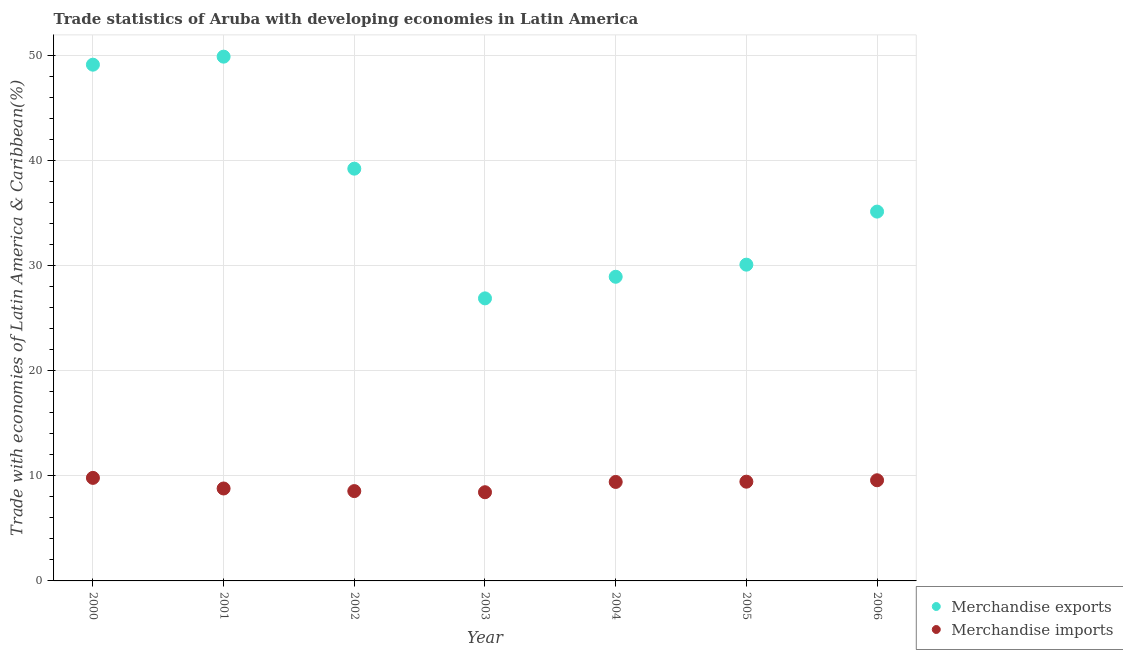Is the number of dotlines equal to the number of legend labels?
Keep it short and to the point. Yes. What is the merchandise exports in 2001?
Provide a succinct answer. 49.86. Across all years, what is the maximum merchandise imports?
Offer a terse response. 9.8. Across all years, what is the minimum merchandise exports?
Make the answer very short. 26.87. In which year was the merchandise exports maximum?
Your answer should be compact. 2001. What is the total merchandise exports in the graph?
Provide a short and direct response. 259.17. What is the difference between the merchandise exports in 2001 and that in 2003?
Offer a very short reply. 22.99. What is the difference between the merchandise exports in 2004 and the merchandise imports in 2005?
Your answer should be compact. 19.49. What is the average merchandise exports per year?
Keep it short and to the point. 37.02. In the year 2005, what is the difference between the merchandise imports and merchandise exports?
Provide a short and direct response. -20.64. In how many years, is the merchandise imports greater than 46 %?
Offer a very short reply. 0. What is the ratio of the merchandise exports in 2001 to that in 2002?
Ensure brevity in your answer.  1.27. Is the merchandise imports in 2000 less than that in 2006?
Provide a succinct answer. No. What is the difference between the highest and the second highest merchandise imports?
Your answer should be compact. 0.23. What is the difference between the highest and the lowest merchandise imports?
Your response must be concise. 1.36. Is the merchandise imports strictly greater than the merchandise exports over the years?
Ensure brevity in your answer.  No. Is the merchandise exports strictly less than the merchandise imports over the years?
Provide a succinct answer. No. How many years are there in the graph?
Your response must be concise. 7. What is the difference between two consecutive major ticks on the Y-axis?
Ensure brevity in your answer.  10. Are the values on the major ticks of Y-axis written in scientific E-notation?
Keep it short and to the point. No. Does the graph contain grids?
Make the answer very short. Yes. Where does the legend appear in the graph?
Ensure brevity in your answer.  Bottom right. How many legend labels are there?
Your answer should be compact. 2. What is the title of the graph?
Make the answer very short. Trade statistics of Aruba with developing economies in Latin America. Does "Chemicals" appear as one of the legend labels in the graph?
Ensure brevity in your answer.  No. What is the label or title of the X-axis?
Make the answer very short. Year. What is the label or title of the Y-axis?
Your answer should be very brief. Trade with economies of Latin America & Caribbean(%). What is the Trade with economies of Latin America & Caribbean(%) in Merchandise exports in 2000?
Give a very brief answer. 49.1. What is the Trade with economies of Latin America & Caribbean(%) of Merchandise imports in 2000?
Your answer should be very brief. 9.8. What is the Trade with economies of Latin America & Caribbean(%) of Merchandise exports in 2001?
Ensure brevity in your answer.  49.86. What is the Trade with economies of Latin America & Caribbean(%) in Merchandise imports in 2001?
Your response must be concise. 8.79. What is the Trade with economies of Latin America & Caribbean(%) of Merchandise exports in 2002?
Offer a very short reply. 39.21. What is the Trade with economies of Latin America & Caribbean(%) in Merchandise imports in 2002?
Offer a very short reply. 8.54. What is the Trade with economies of Latin America & Caribbean(%) in Merchandise exports in 2003?
Your response must be concise. 26.87. What is the Trade with economies of Latin America & Caribbean(%) of Merchandise imports in 2003?
Ensure brevity in your answer.  8.44. What is the Trade with economies of Latin America & Caribbean(%) in Merchandise exports in 2004?
Your answer should be compact. 28.93. What is the Trade with economies of Latin America & Caribbean(%) of Merchandise imports in 2004?
Your answer should be compact. 9.41. What is the Trade with economies of Latin America & Caribbean(%) of Merchandise exports in 2005?
Offer a terse response. 30.08. What is the Trade with economies of Latin America & Caribbean(%) in Merchandise imports in 2005?
Provide a succinct answer. 9.44. What is the Trade with economies of Latin America & Caribbean(%) in Merchandise exports in 2006?
Your answer should be compact. 35.12. What is the Trade with economies of Latin America & Caribbean(%) of Merchandise imports in 2006?
Your response must be concise. 9.57. Across all years, what is the maximum Trade with economies of Latin America & Caribbean(%) of Merchandise exports?
Your response must be concise. 49.86. Across all years, what is the maximum Trade with economies of Latin America & Caribbean(%) of Merchandise imports?
Your answer should be compact. 9.8. Across all years, what is the minimum Trade with economies of Latin America & Caribbean(%) of Merchandise exports?
Provide a short and direct response. 26.87. Across all years, what is the minimum Trade with economies of Latin America & Caribbean(%) of Merchandise imports?
Offer a terse response. 8.44. What is the total Trade with economies of Latin America & Caribbean(%) in Merchandise exports in the graph?
Your answer should be compact. 259.17. What is the total Trade with economies of Latin America & Caribbean(%) in Merchandise imports in the graph?
Make the answer very short. 63.99. What is the difference between the Trade with economies of Latin America & Caribbean(%) in Merchandise exports in 2000 and that in 2001?
Your response must be concise. -0.76. What is the difference between the Trade with economies of Latin America & Caribbean(%) of Merchandise imports in 2000 and that in 2001?
Give a very brief answer. 1.01. What is the difference between the Trade with economies of Latin America & Caribbean(%) in Merchandise exports in 2000 and that in 2002?
Your answer should be compact. 9.89. What is the difference between the Trade with economies of Latin America & Caribbean(%) of Merchandise imports in 2000 and that in 2002?
Your answer should be very brief. 1.26. What is the difference between the Trade with economies of Latin America & Caribbean(%) in Merchandise exports in 2000 and that in 2003?
Give a very brief answer. 22.23. What is the difference between the Trade with economies of Latin America & Caribbean(%) in Merchandise imports in 2000 and that in 2003?
Your response must be concise. 1.36. What is the difference between the Trade with economies of Latin America & Caribbean(%) in Merchandise exports in 2000 and that in 2004?
Keep it short and to the point. 20.17. What is the difference between the Trade with economies of Latin America & Caribbean(%) in Merchandise imports in 2000 and that in 2004?
Offer a terse response. 0.39. What is the difference between the Trade with economies of Latin America & Caribbean(%) in Merchandise exports in 2000 and that in 2005?
Give a very brief answer. 19.02. What is the difference between the Trade with economies of Latin America & Caribbean(%) in Merchandise imports in 2000 and that in 2005?
Ensure brevity in your answer.  0.36. What is the difference between the Trade with economies of Latin America & Caribbean(%) in Merchandise exports in 2000 and that in 2006?
Offer a terse response. 13.97. What is the difference between the Trade with economies of Latin America & Caribbean(%) in Merchandise imports in 2000 and that in 2006?
Your answer should be very brief. 0.23. What is the difference between the Trade with economies of Latin America & Caribbean(%) in Merchandise exports in 2001 and that in 2002?
Your answer should be very brief. 10.65. What is the difference between the Trade with economies of Latin America & Caribbean(%) in Merchandise imports in 2001 and that in 2002?
Ensure brevity in your answer.  0.25. What is the difference between the Trade with economies of Latin America & Caribbean(%) in Merchandise exports in 2001 and that in 2003?
Provide a short and direct response. 22.99. What is the difference between the Trade with economies of Latin America & Caribbean(%) in Merchandise imports in 2001 and that in 2003?
Your answer should be compact. 0.35. What is the difference between the Trade with economies of Latin America & Caribbean(%) of Merchandise exports in 2001 and that in 2004?
Your response must be concise. 20.94. What is the difference between the Trade with economies of Latin America & Caribbean(%) in Merchandise imports in 2001 and that in 2004?
Offer a very short reply. -0.62. What is the difference between the Trade with economies of Latin America & Caribbean(%) in Merchandise exports in 2001 and that in 2005?
Provide a short and direct response. 19.78. What is the difference between the Trade with economies of Latin America & Caribbean(%) in Merchandise imports in 2001 and that in 2005?
Offer a terse response. -0.65. What is the difference between the Trade with economies of Latin America & Caribbean(%) of Merchandise exports in 2001 and that in 2006?
Ensure brevity in your answer.  14.74. What is the difference between the Trade with economies of Latin America & Caribbean(%) in Merchandise imports in 2001 and that in 2006?
Provide a short and direct response. -0.78. What is the difference between the Trade with economies of Latin America & Caribbean(%) of Merchandise exports in 2002 and that in 2003?
Provide a succinct answer. 12.34. What is the difference between the Trade with economies of Latin America & Caribbean(%) of Merchandise imports in 2002 and that in 2003?
Ensure brevity in your answer.  0.11. What is the difference between the Trade with economies of Latin America & Caribbean(%) of Merchandise exports in 2002 and that in 2004?
Offer a terse response. 10.28. What is the difference between the Trade with economies of Latin America & Caribbean(%) in Merchandise imports in 2002 and that in 2004?
Your answer should be very brief. -0.87. What is the difference between the Trade with economies of Latin America & Caribbean(%) in Merchandise exports in 2002 and that in 2005?
Give a very brief answer. 9.13. What is the difference between the Trade with economies of Latin America & Caribbean(%) in Merchandise imports in 2002 and that in 2005?
Your answer should be compact. -0.89. What is the difference between the Trade with economies of Latin America & Caribbean(%) in Merchandise exports in 2002 and that in 2006?
Provide a short and direct response. 4.08. What is the difference between the Trade with economies of Latin America & Caribbean(%) in Merchandise imports in 2002 and that in 2006?
Give a very brief answer. -1.03. What is the difference between the Trade with economies of Latin America & Caribbean(%) in Merchandise exports in 2003 and that in 2004?
Make the answer very short. -2.05. What is the difference between the Trade with economies of Latin America & Caribbean(%) in Merchandise imports in 2003 and that in 2004?
Ensure brevity in your answer.  -0.98. What is the difference between the Trade with economies of Latin America & Caribbean(%) in Merchandise exports in 2003 and that in 2005?
Ensure brevity in your answer.  -3.21. What is the difference between the Trade with economies of Latin America & Caribbean(%) in Merchandise imports in 2003 and that in 2005?
Keep it short and to the point. -1. What is the difference between the Trade with economies of Latin America & Caribbean(%) of Merchandise exports in 2003 and that in 2006?
Provide a short and direct response. -8.25. What is the difference between the Trade with economies of Latin America & Caribbean(%) of Merchandise imports in 2003 and that in 2006?
Offer a terse response. -1.14. What is the difference between the Trade with economies of Latin America & Caribbean(%) of Merchandise exports in 2004 and that in 2005?
Keep it short and to the point. -1.15. What is the difference between the Trade with economies of Latin America & Caribbean(%) in Merchandise imports in 2004 and that in 2005?
Your answer should be very brief. -0.02. What is the difference between the Trade with economies of Latin America & Caribbean(%) in Merchandise exports in 2004 and that in 2006?
Your answer should be very brief. -6.2. What is the difference between the Trade with economies of Latin America & Caribbean(%) in Merchandise imports in 2004 and that in 2006?
Ensure brevity in your answer.  -0.16. What is the difference between the Trade with economies of Latin America & Caribbean(%) of Merchandise exports in 2005 and that in 2006?
Provide a short and direct response. -5.05. What is the difference between the Trade with economies of Latin America & Caribbean(%) in Merchandise imports in 2005 and that in 2006?
Your answer should be compact. -0.14. What is the difference between the Trade with economies of Latin America & Caribbean(%) in Merchandise exports in 2000 and the Trade with economies of Latin America & Caribbean(%) in Merchandise imports in 2001?
Your response must be concise. 40.31. What is the difference between the Trade with economies of Latin America & Caribbean(%) in Merchandise exports in 2000 and the Trade with economies of Latin America & Caribbean(%) in Merchandise imports in 2002?
Give a very brief answer. 40.56. What is the difference between the Trade with economies of Latin America & Caribbean(%) of Merchandise exports in 2000 and the Trade with economies of Latin America & Caribbean(%) of Merchandise imports in 2003?
Provide a short and direct response. 40.66. What is the difference between the Trade with economies of Latin America & Caribbean(%) of Merchandise exports in 2000 and the Trade with economies of Latin America & Caribbean(%) of Merchandise imports in 2004?
Your response must be concise. 39.68. What is the difference between the Trade with economies of Latin America & Caribbean(%) of Merchandise exports in 2000 and the Trade with economies of Latin America & Caribbean(%) of Merchandise imports in 2005?
Keep it short and to the point. 39.66. What is the difference between the Trade with economies of Latin America & Caribbean(%) of Merchandise exports in 2000 and the Trade with economies of Latin America & Caribbean(%) of Merchandise imports in 2006?
Offer a very short reply. 39.53. What is the difference between the Trade with economies of Latin America & Caribbean(%) of Merchandise exports in 2001 and the Trade with economies of Latin America & Caribbean(%) of Merchandise imports in 2002?
Provide a succinct answer. 41.32. What is the difference between the Trade with economies of Latin America & Caribbean(%) of Merchandise exports in 2001 and the Trade with economies of Latin America & Caribbean(%) of Merchandise imports in 2003?
Offer a very short reply. 41.43. What is the difference between the Trade with economies of Latin America & Caribbean(%) in Merchandise exports in 2001 and the Trade with economies of Latin America & Caribbean(%) in Merchandise imports in 2004?
Your answer should be compact. 40.45. What is the difference between the Trade with economies of Latin America & Caribbean(%) of Merchandise exports in 2001 and the Trade with economies of Latin America & Caribbean(%) of Merchandise imports in 2005?
Offer a terse response. 40.42. What is the difference between the Trade with economies of Latin America & Caribbean(%) in Merchandise exports in 2001 and the Trade with economies of Latin America & Caribbean(%) in Merchandise imports in 2006?
Your answer should be compact. 40.29. What is the difference between the Trade with economies of Latin America & Caribbean(%) of Merchandise exports in 2002 and the Trade with economies of Latin America & Caribbean(%) of Merchandise imports in 2003?
Offer a very short reply. 30.77. What is the difference between the Trade with economies of Latin America & Caribbean(%) in Merchandise exports in 2002 and the Trade with economies of Latin America & Caribbean(%) in Merchandise imports in 2004?
Give a very brief answer. 29.8. What is the difference between the Trade with economies of Latin America & Caribbean(%) in Merchandise exports in 2002 and the Trade with economies of Latin America & Caribbean(%) in Merchandise imports in 2005?
Your answer should be very brief. 29.77. What is the difference between the Trade with economies of Latin America & Caribbean(%) of Merchandise exports in 2002 and the Trade with economies of Latin America & Caribbean(%) of Merchandise imports in 2006?
Provide a short and direct response. 29.64. What is the difference between the Trade with economies of Latin America & Caribbean(%) in Merchandise exports in 2003 and the Trade with economies of Latin America & Caribbean(%) in Merchandise imports in 2004?
Offer a terse response. 17.46. What is the difference between the Trade with economies of Latin America & Caribbean(%) in Merchandise exports in 2003 and the Trade with economies of Latin America & Caribbean(%) in Merchandise imports in 2005?
Offer a terse response. 17.43. What is the difference between the Trade with economies of Latin America & Caribbean(%) in Merchandise exports in 2003 and the Trade with economies of Latin America & Caribbean(%) in Merchandise imports in 2006?
Your answer should be very brief. 17.3. What is the difference between the Trade with economies of Latin America & Caribbean(%) of Merchandise exports in 2004 and the Trade with economies of Latin America & Caribbean(%) of Merchandise imports in 2005?
Give a very brief answer. 19.49. What is the difference between the Trade with economies of Latin America & Caribbean(%) of Merchandise exports in 2004 and the Trade with economies of Latin America & Caribbean(%) of Merchandise imports in 2006?
Make the answer very short. 19.35. What is the difference between the Trade with economies of Latin America & Caribbean(%) in Merchandise exports in 2005 and the Trade with economies of Latin America & Caribbean(%) in Merchandise imports in 2006?
Your answer should be compact. 20.51. What is the average Trade with economies of Latin America & Caribbean(%) of Merchandise exports per year?
Provide a short and direct response. 37.02. What is the average Trade with economies of Latin America & Caribbean(%) of Merchandise imports per year?
Your answer should be very brief. 9.14. In the year 2000, what is the difference between the Trade with economies of Latin America & Caribbean(%) in Merchandise exports and Trade with economies of Latin America & Caribbean(%) in Merchandise imports?
Offer a very short reply. 39.3. In the year 2001, what is the difference between the Trade with economies of Latin America & Caribbean(%) in Merchandise exports and Trade with economies of Latin America & Caribbean(%) in Merchandise imports?
Offer a very short reply. 41.07. In the year 2002, what is the difference between the Trade with economies of Latin America & Caribbean(%) of Merchandise exports and Trade with economies of Latin America & Caribbean(%) of Merchandise imports?
Your answer should be very brief. 30.67. In the year 2003, what is the difference between the Trade with economies of Latin America & Caribbean(%) in Merchandise exports and Trade with economies of Latin America & Caribbean(%) in Merchandise imports?
Your answer should be compact. 18.44. In the year 2004, what is the difference between the Trade with economies of Latin America & Caribbean(%) of Merchandise exports and Trade with economies of Latin America & Caribbean(%) of Merchandise imports?
Make the answer very short. 19.51. In the year 2005, what is the difference between the Trade with economies of Latin America & Caribbean(%) of Merchandise exports and Trade with economies of Latin America & Caribbean(%) of Merchandise imports?
Your answer should be compact. 20.64. In the year 2006, what is the difference between the Trade with economies of Latin America & Caribbean(%) in Merchandise exports and Trade with economies of Latin America & Caribbean(%) in Merchandise imports?
Ensure brevity in your answer.  25.55. What is the ratio of the Trade with economies of Latin America & Caribbean(%) of Merchandise exports in 2000 to that in 2001?
Offer a very short reply. 0.98. What is the ratio of the Trade with economies of Latin America & Caribbean(%) in Merchandise imports in 2000 to that in 2001?
Ensure brevity in your answer.  1.11. What is the ratio of the Trade with economies of Latin America & Caribbean(%) of Merchandise exports in 2000 to that in 2002?
Make the answer very short. 1.25. What is the ratio of the Trade with economies of Latin America & Caribbean(%) in Merchandise imports in 2000 to that in 2002?
Your answer should be very brief. 1.15. What is the ratio of the Trade with economies of Latin America & Caribbean(%) of Merchandise exports in 2000 to that in 2003?
Make the answer very short. 1.83. What is the ratio of the Trade with economies of Latin America & Caribbean(%) in Merchandise imports in 2000 to that in 2003?
Make the answer very short. 1.16. What is the ratio of the Trade with economies of Latin America & Caribbean(%) in Merchandise exports in 2000 to that in 2004?
Your answer should be compact. 1.7. What is the ratio of the Trade with economies of Latin America & Caribbean(%) of Merchandise imports in 2000 to that in 2004?
Provide a succinct answer. 1.04. What is the ratio of the Trade with economies of Latin America & Caribbean(%) in Merchandise exports in 2000 to that in 2005?
Provide a succinct answer. 1.63. What is the ratio of the Trade with economies of Latin America & Caribbean(%) in Merchandise imports in 2000 to that in 2005?
Your answer should be compact. 1.04. What is the ratio of the Trade with economies of Latin America & Caribbean(%) of Merchandise exports in 2000 to that in 2006?
Keep it short and to the point. 1.4. What is the ratio of the Trade with economies of Latin America & Caribbean(%) of Merchandise imports in 2000 to that in 2006?
Give a very brief answer. 1.02. What is the ratio of the Trade with economies of Latin America & Caribbean(%) of Merchandise exports in 2001 to that in 2002?
Offer a terse response. 1.27. What is the ratio of the Trade with economies of Latin America & Caribbean(%) in Merchandise imports in 2001 to that in 2002?
Offer a very short reply. 1.03. What is the ratio of the Trade with economies of Latin America & Caribbean(%) in Merchandise exports in 2001 to that in 2003?
Your response must be concise. 1.86. What is the ratio of the Trade with economies of Latin America & Caribbean(%) in Merchandise imports in 2001 to that in 2003?
Offer a very short reply. 1.04. What is the ratio of the Trade with economies of Latin America & Caribbean(%) of Merchandise exports in 2001 to that in 2004?
Keep it short and to the point. 1.72. What is the ratio of the Trade with economies of Latin America & Caribbean(%) of Merchandise imports in 2001 to that in 2004?
Offer a terse response. 0.93. What is the ratio of the Trade with economies of Latin America & Caribbean(%) in Merchandise exports in 2001 to that in 2005?
Your answer should be very brief. 1.66. What is the ratio of the Trade with economies of Latin America & Caribbean(%) of Merchandise imports in 2001 to that in 2005?
Provide a short and direct response. 0.93. What is the ratio of the Trade with economies of Latin America & Caribbean(%) of Merchandise exports in 2001 to that in 2006?
Offer a very short reply. 1.42. What is the ratio of the Trade with economies of Latin America & Caribbean(%) in Merchandise imports in 2001 to that in 2006?
Ensure brevity in your answer.  0.92. What is the ratio of the Trade with economies of Latin America & Caribbean(%) in Merchandise exports in 2002 to that in 2003?
Provide a succinct answer. 1.46. What is the ratio of the Trade with economies of Latin America & Caribbean(%) of Merchandise imports in 2002 to that in 2003?
Your answer should be very brief. 1.01. What is the ratio of the Trade with economies of Latin America & Caribbean(%) in Merchandise exports in 2002 to that in 2004?
Provide a short and direct response. 1.36. What is the ratio of the Trade with economies of Latin America & Caribbean(%) of Merchandise imports in 2002 to that in 2004?
Provide a short and direct response. 0.91. What is the ratio of the Trade with economies of Latin America & Caribbean(%) in Merchandise exports in 2002 to that in 2005?
Provide a succinct answer. 1.3. What is the ratio of the Trade with economies of Latin America & Caribbean(%) of Merchandise imports in 2002 to that in 2005?
Your response must be concise. 0.91. What is the ratio of the Trade with economies of Latin America & Caribbean(%) in Merchandise exports in 2002 to that in 2006?
Your answer should be compact. 1.12. What is the ratio of the Trade with economies of Latin America & Caribbean(%) in Merchandise imports in 2002 to that in 2006?
Give a very brief answer. 0.89. What is the ratio of the Trade with economies of Latin America & Caribbean(%) in Merchandise exports in 2003 to that in 2004?
Provide a succinct answer. 0.93. What is the ratio of the Trade with economies of Latin America & Caribbean(%) of Merchandise imports in 2003 to that in 2004?
Ensure brevity in your answer.  0.9. What is the ratio of the Trade with economies of Latin America & Caribbean(%) in Merchandise exports in 2003 to that in 2005?
Provide a succinct answer. 0.89. What is the ratio of the Trade with economies of Latin America & Caribbean(%) in Merchandise imports in 2003 to that in 2005?
Keep it short and to the point. 0.89. What is the ratio of the Trade with economies of Latin America & Caribbean(%) in Merchandise exports in 2003 to that in 2006?
Give a very brief answer. 0.77. What is the ratio of the Trade with economies of Latin America & Caribbean(%) of Merchandise imports in 2003 to that in 2006?
Provide a succinct answer. 0.88. What is the ratio of the Trade with economies of Latin America & Caribbean(%) of Merchandise exports in 2004 to that in 2005?
Your response must be concise. 0.96. What is the ratio of the Trade with economies of Latin America & Caribbean(%) in Merchandise imports in 2004 to that in 2005?
Offer a terse response. 1. What is the ratio of the Trade with economies of Latin America & Caribbean(%) of Merchandise exports in 2004 to that in 2006?
Ensure brevity in your answer.  0.82. What is the ratio of the Trade with economies of Latin America & Caribbean(%) in Merchandise imports in 2004 to that in 2006?
Give a very brief answer. 0.98. What is the ratio of the Trade with economies of Latin America & Caribbean(%) of Merchandise exports in 2005 to that in 2006?
Offer a very short reply. 0.86. What is the ratio of the Trade with economies of Latin America & Caribbean(%) of Merchandise imports in 2005 to that in 2006?
Make the answer very short. 0.99. What is the difference between the highest and the second highest Trade with economies of Latin America & Caribbean(%) of Merchandise exports?
Give a very brief answer. 0.76. What is the difference between the highest and the second highest Trade with economies of Latin America & Caribbean(%) in Merchandise imports?
Your answer should be very brief. 0.23. What is the difference between the highest and the lowest Trade with economies of Latin America & Caribbean(%) in Merchandise exports?
Give a very brief answer. 22.99. What is the difference between the highest and the lowest Trade with economies of Latin America & Caribbean(%) in Merchandise imports?
Keep it short and to the point. 1.36. 